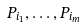Convert formula to latex. <formula><loc_0><loc_0><loc_500><loc_500>P _ { i _ { 1 } } , \dots , P _ { i _ { m } }</formula> 